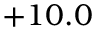<formula> <loc_0><loc_0><loc_500><loc_500>+ 1 0 . 0</formula> 